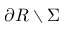<formula> <loc_0><loc_0><loc_500><loc_500>\partial R \ \Sigma</formula> 